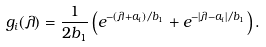<formula> <loc_0><loc_0><loc_500><loc_500>g _ { i } ( \lambda ) = \frac { 1 } { 2 b _ { 1 } } \left ( e ^ { - ( \lambda + a _ { i } ) / b _ { 1 } } + e ^ { - | \lambda - a _ { i } | / b _ { 1 } } \right ) .</formula> 